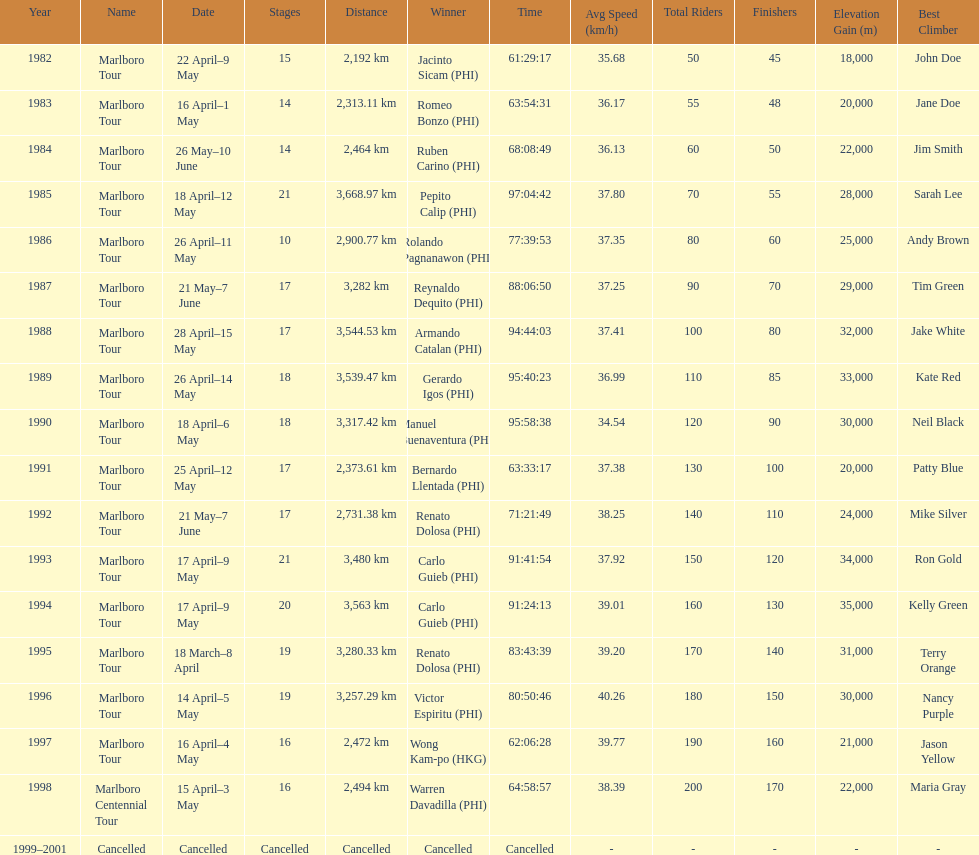Can you give me this table as a dict? {'header': ['Year', 'Name', 'Date', 'Stages', 'Distance', 'Winner', 'Time', 'Avg Speed (km/h)', 'Total Riders', 'Finishers', 'Elevation Gain (m)', 'Best Climber'], 'rows': [['1982', 'Marlboro Tour', '22 April–9 May', '15', '2,192\xa0km', 'Jacinto Sicam\xa0(PHI)', '61:29:17', '35.68', '50', '45', '18,000', 'John Doe'], ['1983', 'Marlboro Tour', '16 April–1 May', '14', '2,313.11\xa0km', 'Romeo Bonzo\xa0(PHI)', '63:54:31', '36.17', '55', '48', '20,000', 'Jane Doe'], ['1984', 'Marlboro Tour', '26 May–10 June', '14', '2,464\xa0km', 'Ruben Carino\xa0(PHI)', '68:08:49', '36.13', '60', '50', '22,000', 'Jim Smith'], ['1985', 'Marlboro Tour', '18 April–12 May', '21', '3,668.97\xa0km', 'Pepito Calip\xa0(PHI)', '97:04:42', '37.80', '70', '55', '28,000', 'Sarah Lee'], ['1986', 'Marlboro Tour', '26 April–11 May', '10', '2,900.77\xa0km', 'Rolando Pagnanawon\xa0(PHI)', '77:39:53', '37.35', '80', '60', '25,000', 'Andy Brown'], ['1987', 'Marlboro Tour', '21 May–7 June', '17', '3,282\xa0km', 'Reynaldo Dequito\xa0(PHI)', '88:06:50', '37.25', '90', '70', '29,000', 'Tim Green'], ['1988', 'Marlboro Tour', '28 April–15 May', '17', '3,544.53\xa0km', 'Armando Catalan\xa0(PHI)', '94:44:03', '37.41', '100', '80', '32,000', 'Jake White'], ['1989', 'Marlboro Tour', '26 April–14 May', '18', '3,539.47\xa0km', 'Gerardo Igos\xa0(PHI)', '95:40:23', '36.99', '110', '85', '33,000', 'Kate Red'], ['1990', 'Marlboro Tour', '18 April–6 May', '18', '3,317.42\xa0km', 'Manuel Buenaventura\xa0(PHI)', '95:58:38', '34.54', '120', '90', '30,000', 'Neil Black'], ['1991', 'Marlboro Tour', '25 April–12 May', '17', '2,373.61\xa0km', 'Bernardo Llentada\xa0(PHI)', '63:33:17', '37.38', '130', '100', '20,000', 'Patty Blue'], ['1992', 'Marlboro Tour', '21 May–7 June', '17', '2,731.38\xa0km', 'Renato Dolosa\xa0(PHI)', '71:21:49', '38.25', '140', '110', '24,000', 'Mike Silver'], ['1993', 'Marlboro Tour', '17 April–9 May', '21', '3,480\xa0km', 'Carlo Guieb\xa0(PHI)', '91:41:54', '37.92', '150', '120', '34,000', 'Ron Gold'], ['1994', 'Marlboro Tour', '17 April–9 May', '20', '3,563\xa0km', 'Carlo Guieb\xa0(PHI)', '91:24:13', '39.01', '160', '130', '35,000', 'Kelly Green'], ['1995', 'Marlboro Tour', '18 March–8 April', '19', '3,280.33\xa0km', 'Renato Dolosa\xa0(PHI)', '83:43:39', '39.20', '170', '140', '31,000', 'Terry Orange'], ['1996', 'Marlboro Tour', '14 April–5 May', '19', '3,257.29\xa0km', 'Victor Espiritu\xa0(PHI)', '80:50:46', '40.26', '180', '150', '30,000', 'Nancy Purple'], ['1997', 'Marlboro Tour', '16 April–4 May', '16', '2,472\xa0km', 'Wong Kam-po\xa0(HKG)', '62:06:28', '39.77', '190', '160', '21,000', 'Jason Yellow'], ['1998', 'Marlboro Centennial Tour', '15 April–3 May', '16', '2,494\xa0km', 'Warren Davadilla\xa0(PHI)', '64:58:57', '38.39', '200', '170', '22,000', 'Maria Gray'], ['1999–2001', 'Cancelled', 'Cancelled', 'Cancelled', 'Cancelled', 'Cancelled', 'Cancelled', '-', '-', '-', '-', '-']]} Who won the most marlboro tours? Carlo Guieb. 